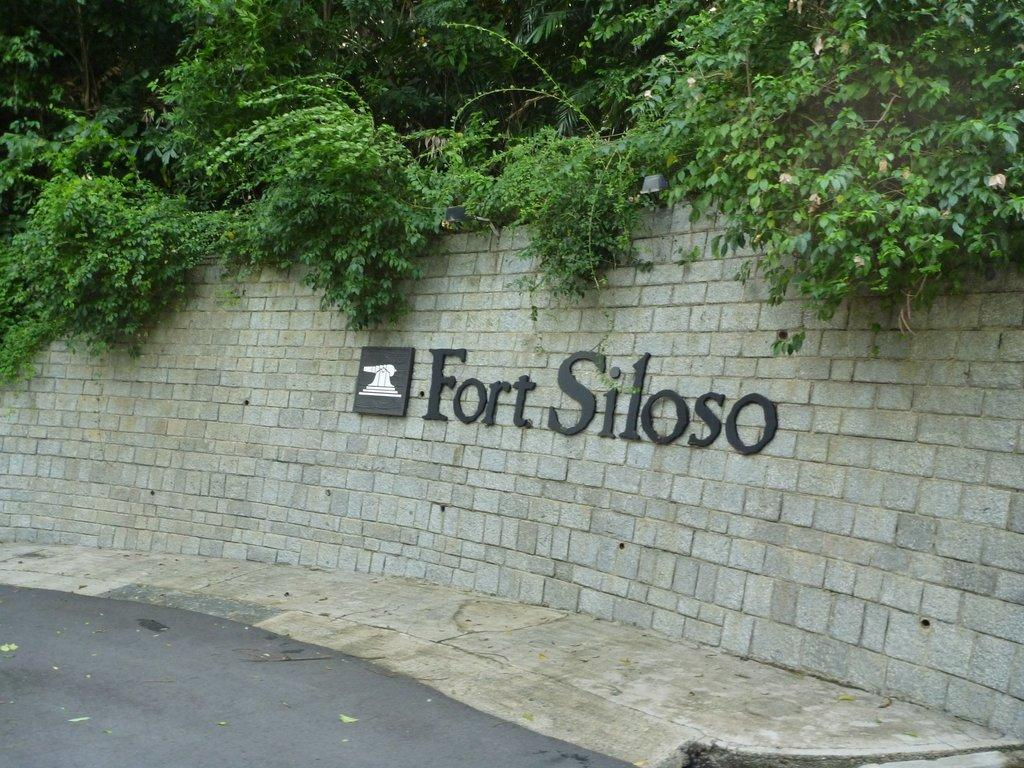What is written on the wall near the road in the image? The name "Fort Siloso" is written on the wall. What else is present on the wall besides the name? There is a symbol associated with Fort Siloso on the wall. What can be seen on the top of the road in the image? Plants and bushes are visible on the top of the road. What time of day is it in the image, and who made the request for the beginner to start? The time of day is not mentioned in the image, and there is no information about a request or a beginner starting anything. 